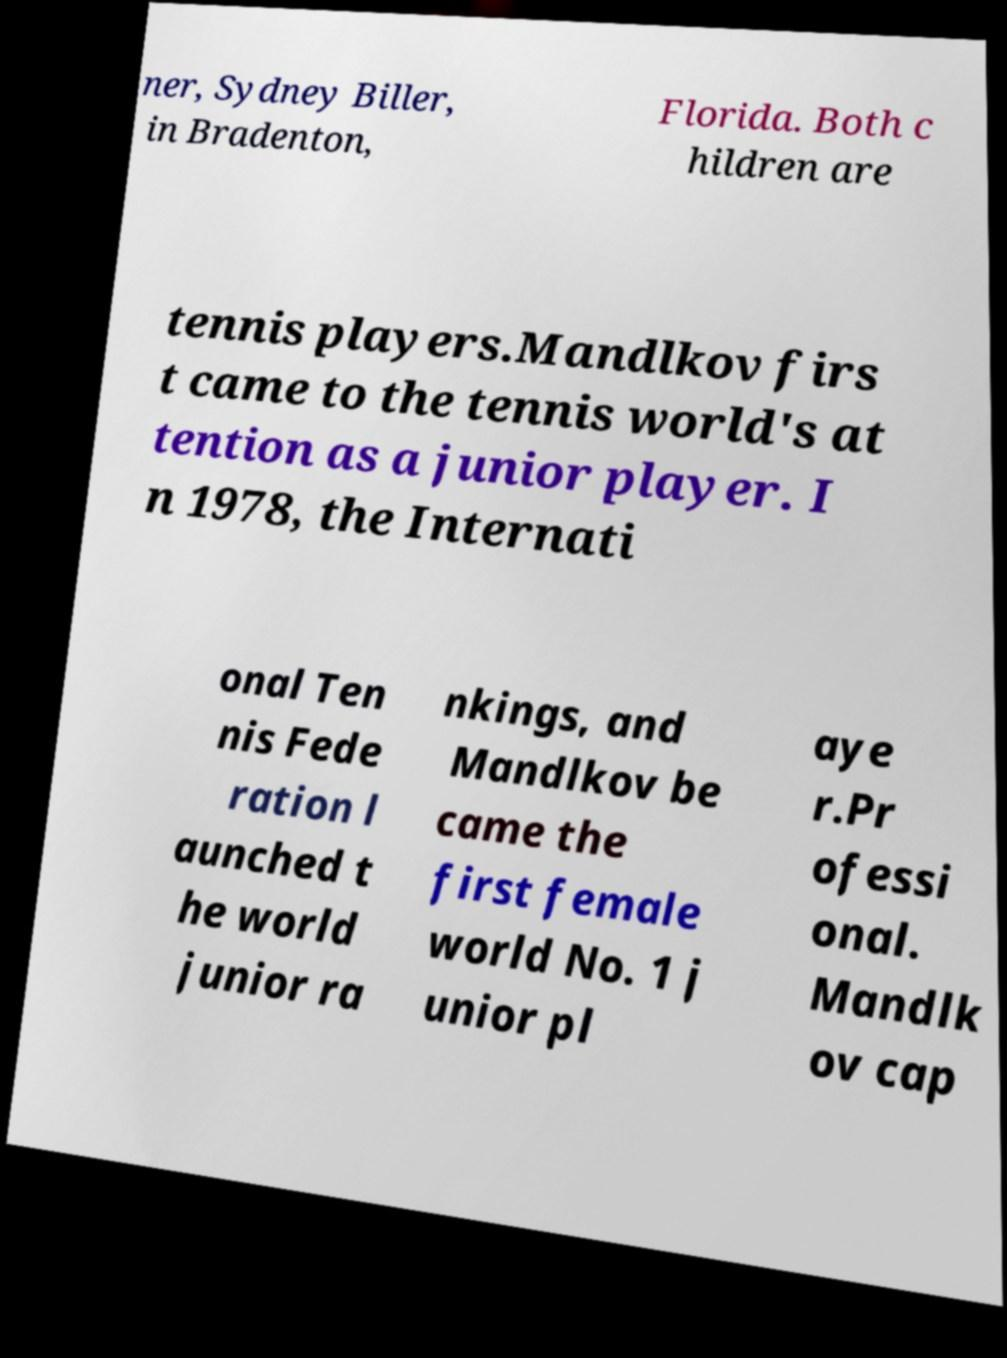I need the written content from this picture converted into text. Can you do that? ner, Sydney Biller, in Bradenton, Florida. Both c hildren are tennis players.Mandlkov firs t came to the tennis world's at tention as a junior player. I n 1978, the Internati onal Ten nis Fede ration l aunched t he world junior ra nkings, and Mandlkov be came the first female world No. 1 j unior pl aye r.Pr ofessi onal. Mandlk ov cap 